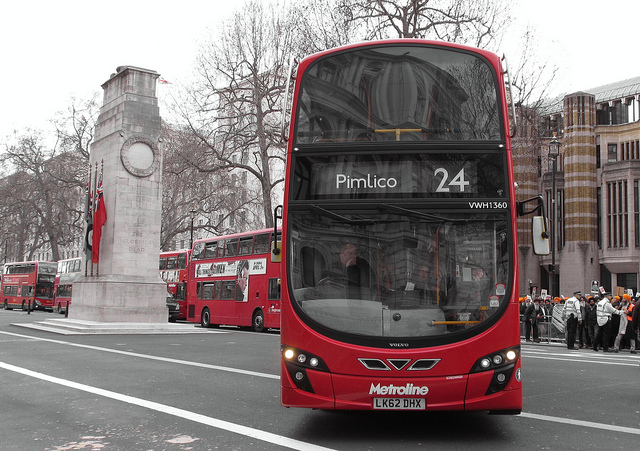Read and extract the text from this image. Pimlico 24 VWH1360 Metroline LK62 DHX 